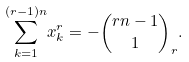<formula> <loc_0><loc_0><loc_500><loc_500>\underset { k = 1 } { \overset { ( r - 1 ) n } { \sum } } x _ { k } ^ { r } = - \binom { r n - 1 } { 1 } _ { r } { . }</formula> 